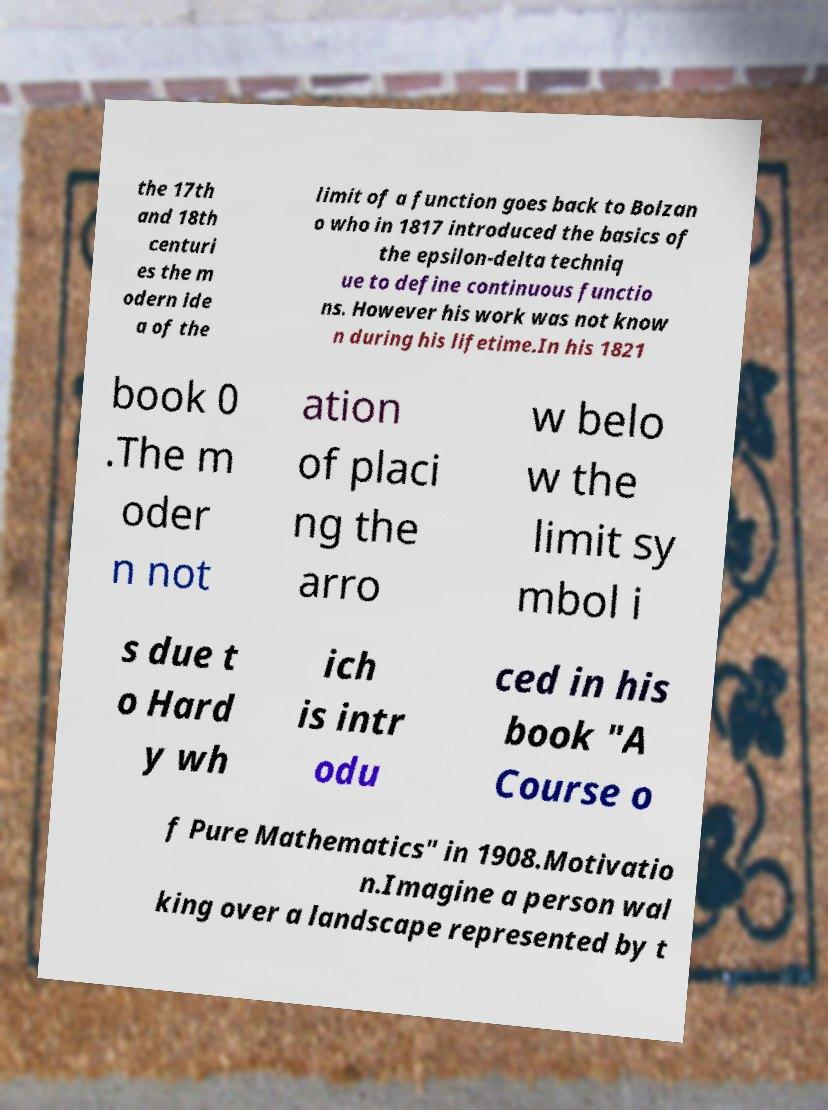Please read and relay the text visible in this image. What does it say? the 17th and 18th centuri es the m odern ide a of the limit of a function goes back to Bolzan o who in 1817 introduced the basics of the epsilon-delta techniq ue to define continuous functio ns. However his work was not know n during his lifetime.In his 1821 book 0 .The m oder n not ation of placi ng the arro w belo w the limit sy mbol i s due t o Hard y wh ich is intr odu ced in his book "A Course o f Pure Mathematics" in 1908.Motivatio n.Imagine a person wal king over a landscape represented by t 